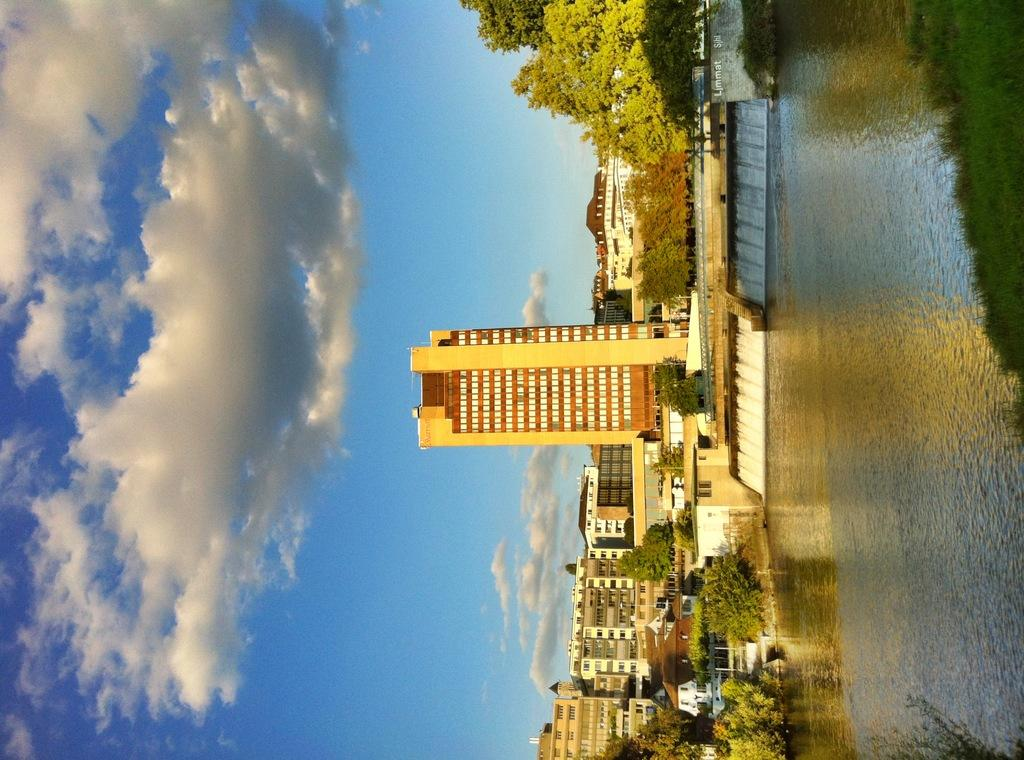What can be seen on the right side of the image? There is water on the right side of the image. What is located near the water? There are buildings and trees near the water. What is visible on the left side of the image? The sky is visible on the left side of the image. What can be observed in the sky? Clouds are present in the sky. Can you see a kiss happening between the trees in the image? There is no kiss or any indication of a kiss in the image; it features water, buildings, trees, sky, and clouds. What type of plants are growing near the water in the image? The image does not specify the type of plants near the water; it only shows trees. 